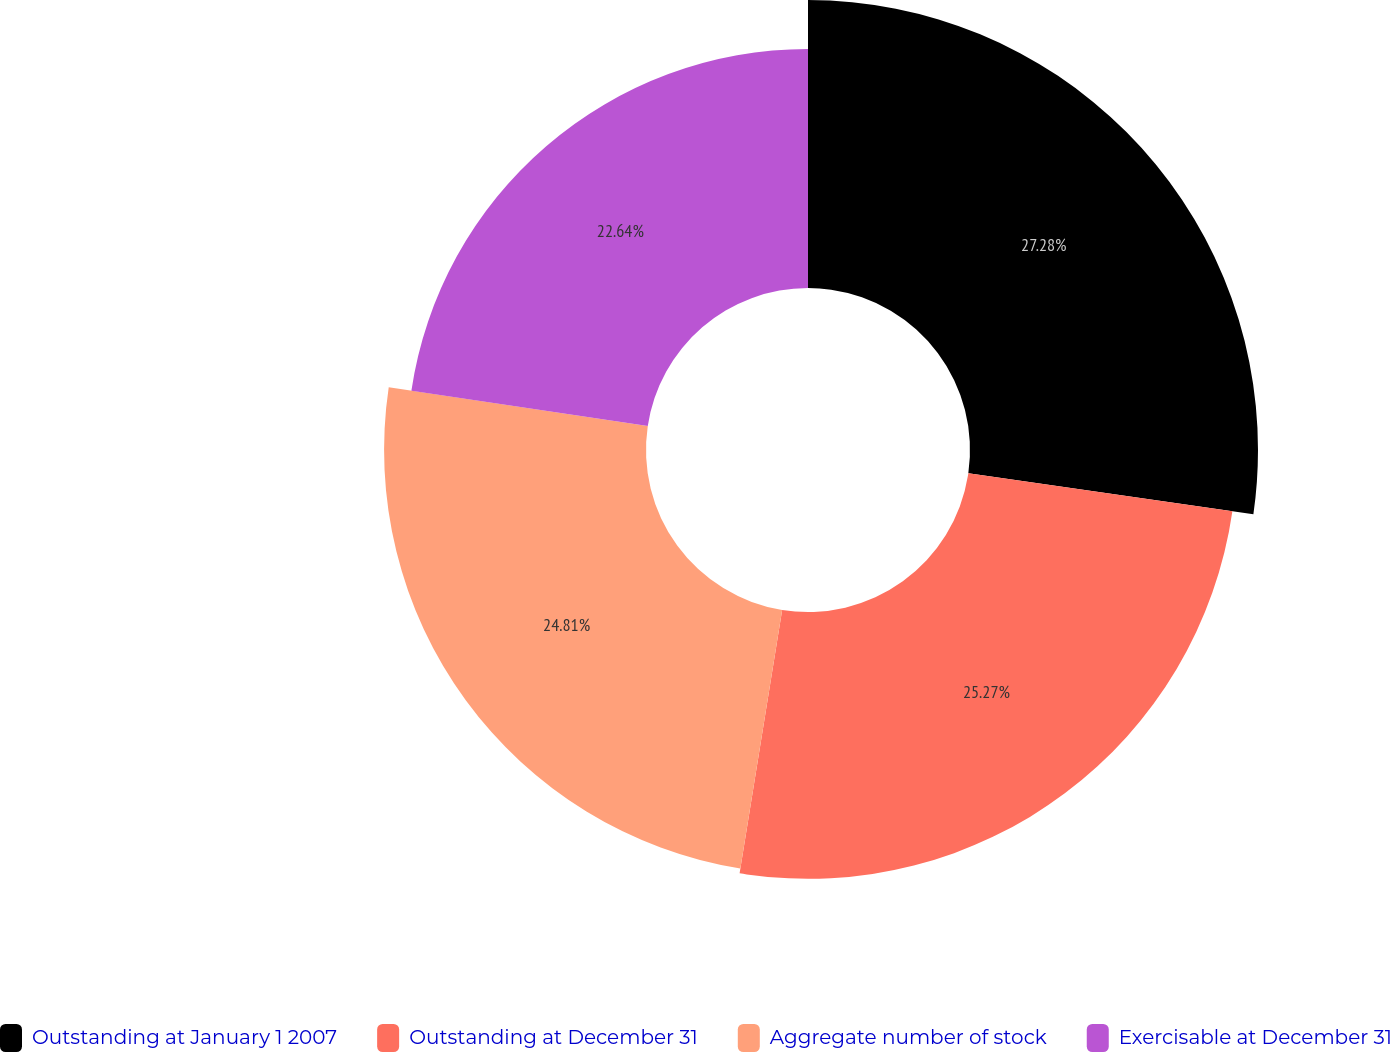Convert chart. <chart><loc_0><loc_0><loc_500><loc_500><pie_chart><fcel>Outstanding at January 1 2007<fcel>Outstanding at December 31<fcel>Aggregate number of stock<fcel>Exercisable at December 31<nl><fcel>27.28%<fcel>25.27%<fcel>24.81%<fcel>22.64%<nl></chart> 